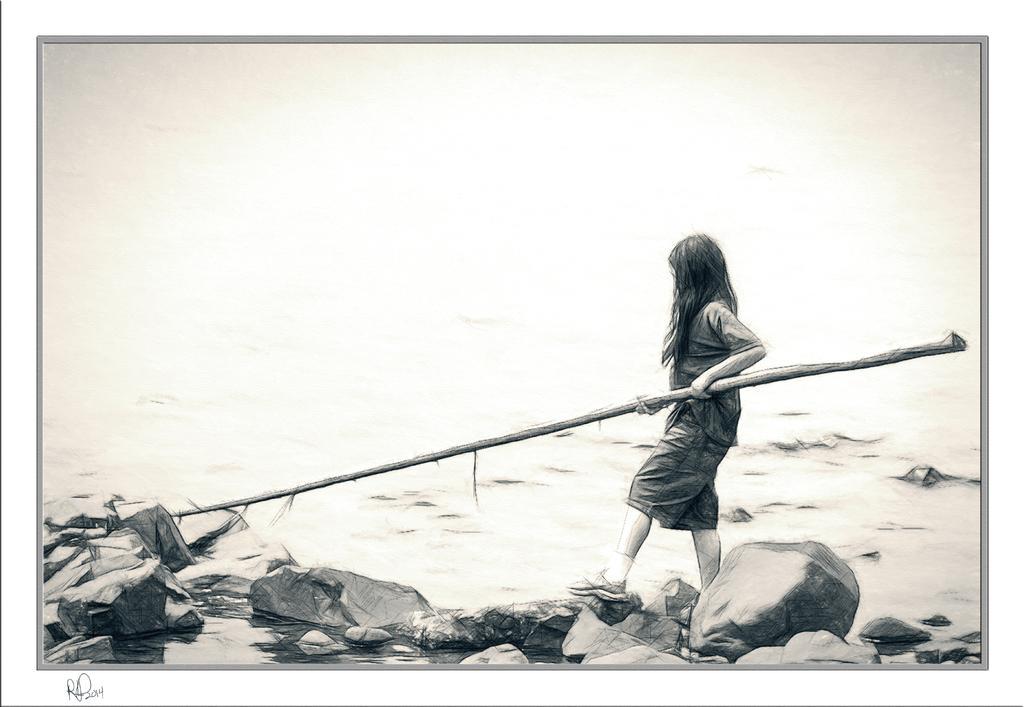In one or two sentences, can you explain what this image depicts? In this image we can see black and white picture of a drawing, in which we can see a woman holding a stick in her hands is standing on rocks placed in water. At the bottom of the Image we can see some text. 